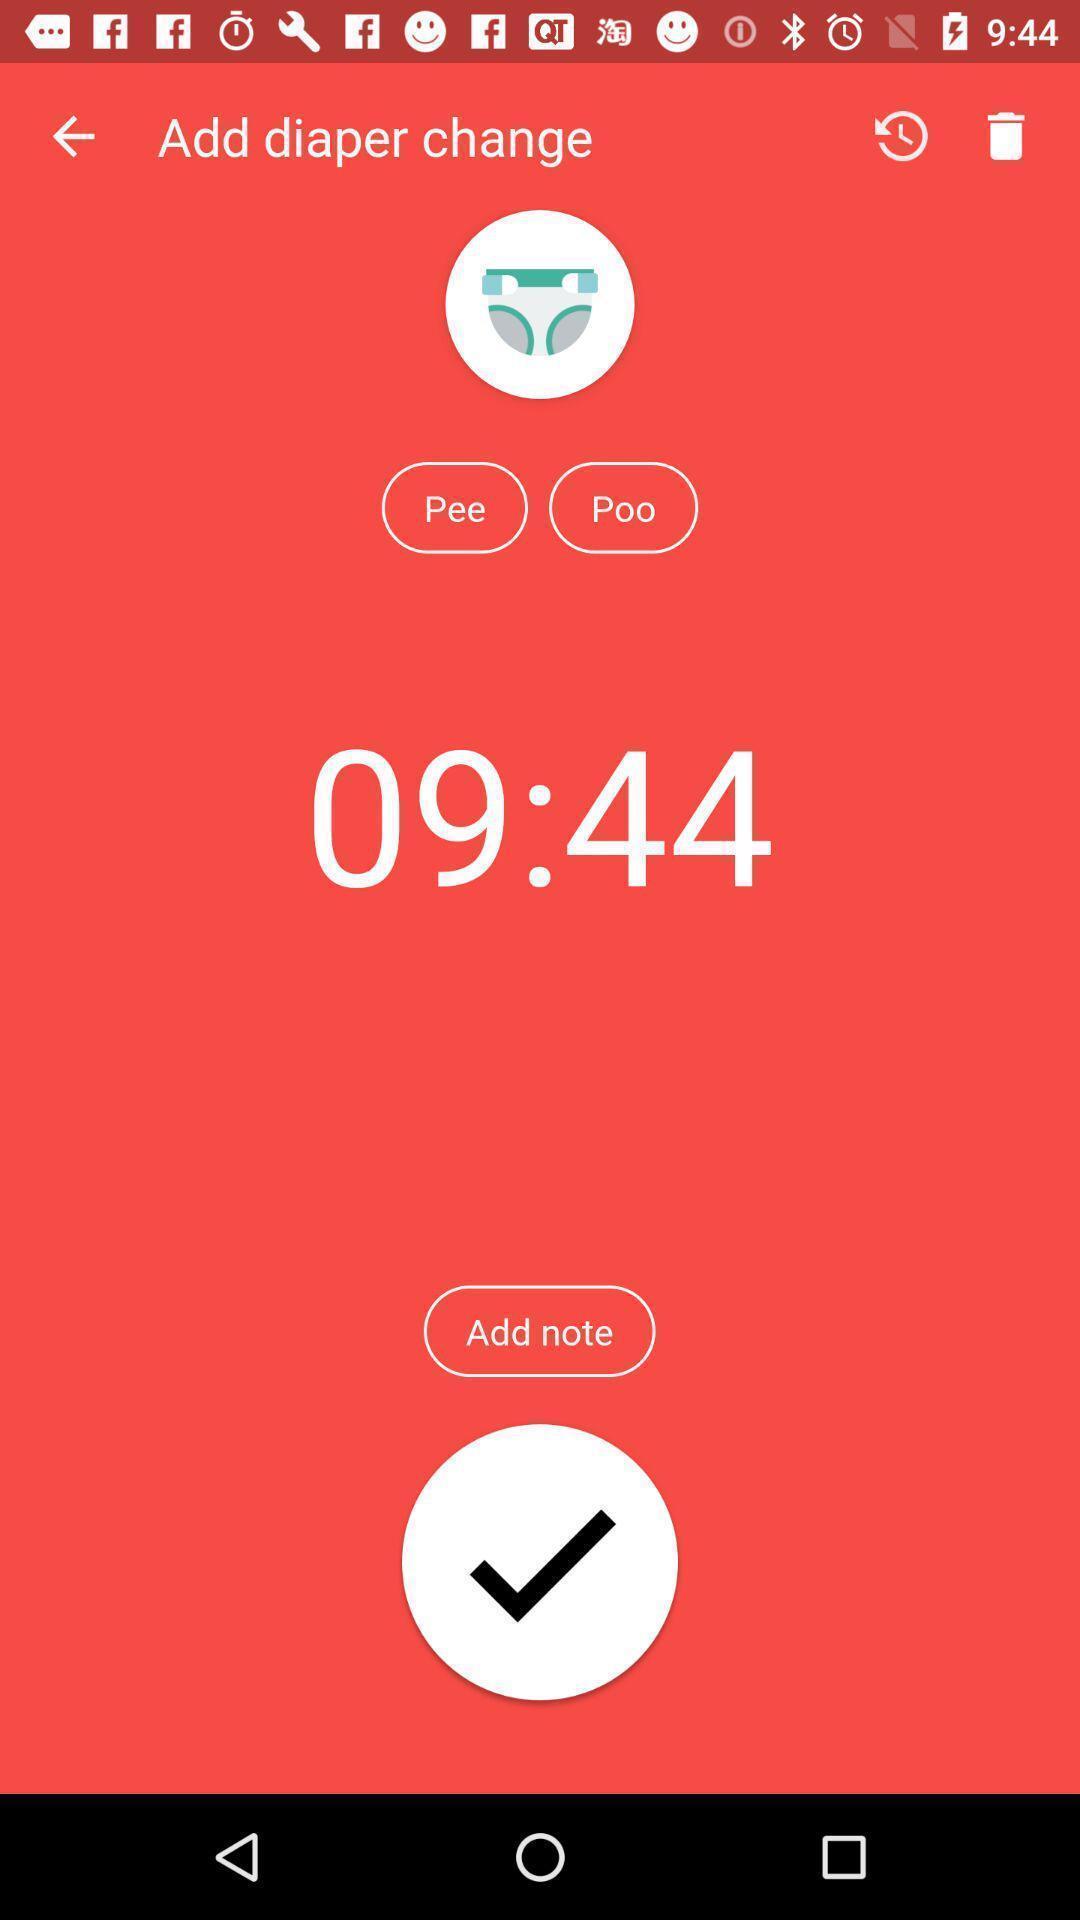Describe the content in this image. Screen showing save note option of a baby care app. 